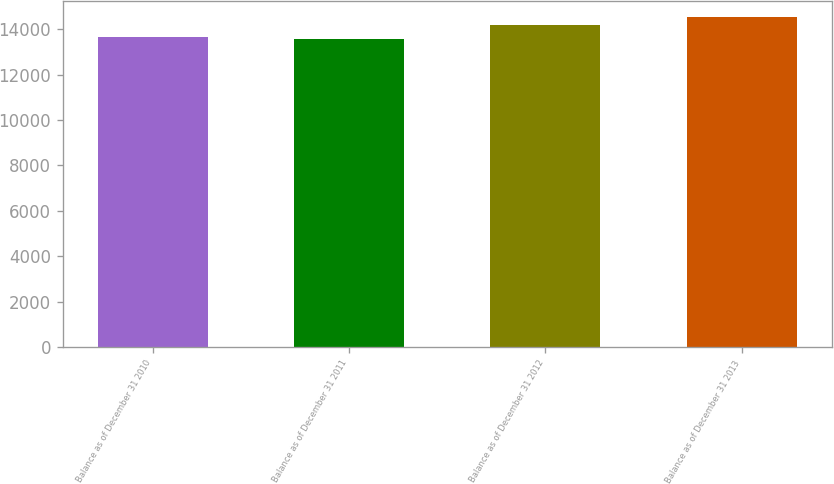Convert chart. <chart><loc_0><loc_0><loc_500><loc_500><bar_chart><fcel>Balance as of December 31 2010<fcel>Balance as of December 31 2011<fcel>Balance as of December 31 2012<fcel>Balance as of December 31 2013<nl><fcel>13669.9<fcel>13576<fcel>14179<fcel>14515<nl></chart> 